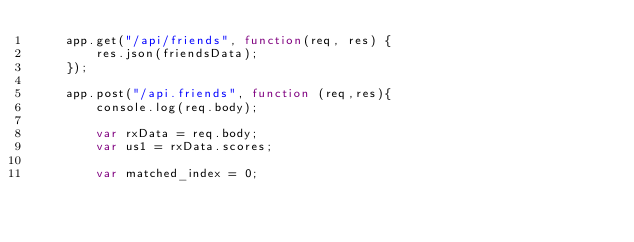<code> <loc_0><loc_0><loc_500><loc_500><_JavaScript_>    app.get("/api/friends", function(req, res) {
        res.json(friendsData);
    });

    app.post("/api.friends", function (req,res){
        console.log(req.body);

        var rxData = req.body;
        var us1 = rxData.scores;

        var matched_index = 0;</code> 